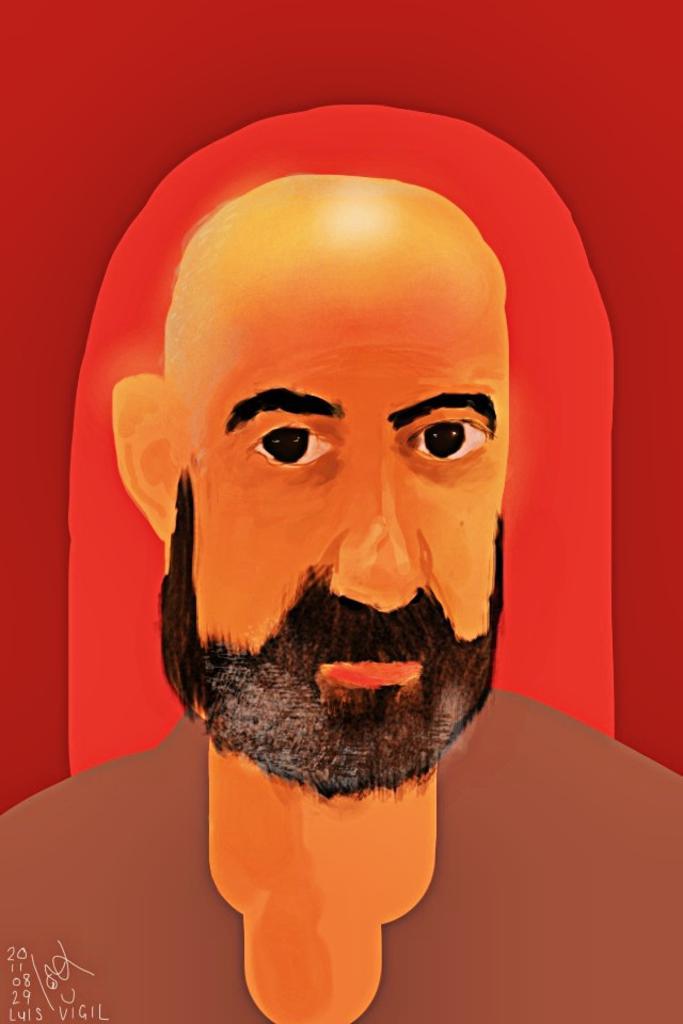How would you summarize this image in a sentence or two? This picture shows a painting of a man and we see some numbers on the left corner. 